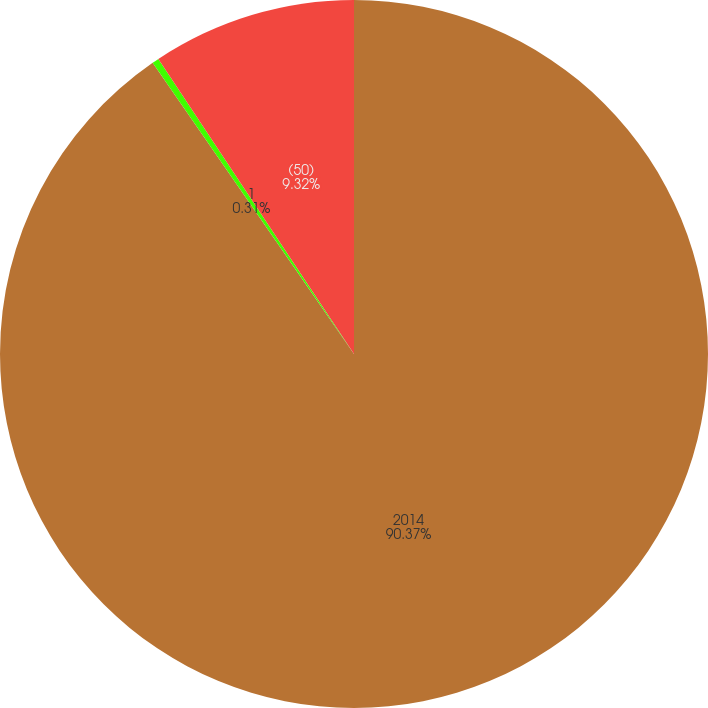Convert chart. <chart><loc_0><loc_0><loc_500><loc_500><pie_chart><fcel>2014<fcel>1<fcel>(50)<nl><fcel>90.37%<fcel>0.31%<fcel>9.32%<nl></chart> 